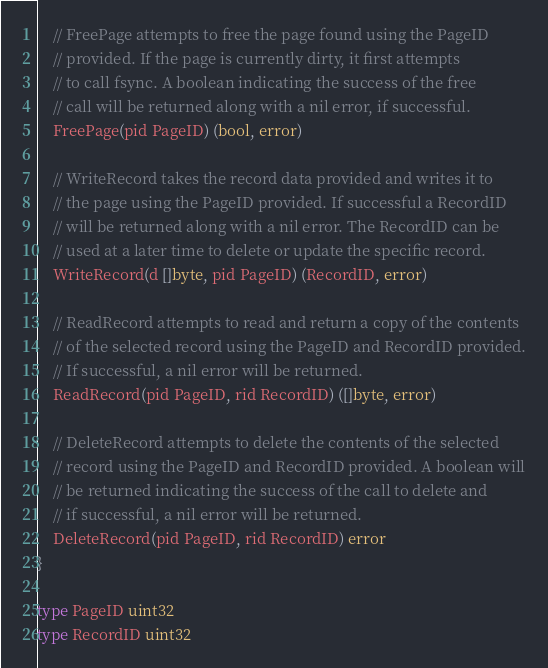<code> <loc_0><loc_0><loc_500><loc_500><_Go_>	// FreePage attempts to free the page found using the PageID
	// provided. If the page is currently dirty, it first attempts
	// to call fsync. A boolean indicating the success of the free
	// call will be returned along with a nil error, if successful.
	FreePage(pid PageID) (bool, error)

	// WriteRecord takes the record data provided and writes it to
	// the page using the PageID provided. If successful a RecordID
	// will be returned along with a nil error. The RecordID can be
	// used at a later time to delete or update the specific record.
	WriteRecord(d []byte, pid PageID) (RecordID, error)

	// ReadRecord attempts to read and return a copy of the contents
	// of the selected record using the PageID and RecordID provided.
	// If successful, a nil error will be returned.
	ReadRecord(pid PageID, rid RecordID) ([]byte, error)

	// DeleteRecord attempts to delete the contents of the selected
	// record using the PageID and RecordID provided. A boolean will
	// be returned indicating the success of the call to delete and
	// if successful, a nil error will be returned.
	DeleteRecord(pid PageID, rid RecordID) error
}

type PageID uint32
type RecordID uint32
</code> 